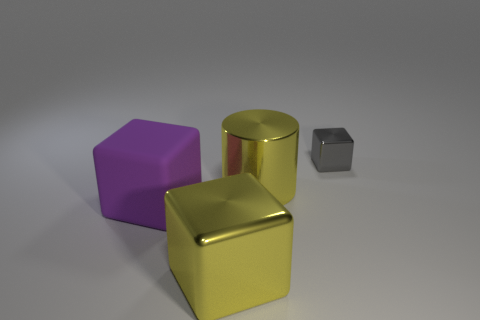Subtract all large matte cubes. How many cubes are left? 2 Subtract all purple cubes. How many cubes are left? 2 Subtract 1 cylinders. How many cylinders are left? 0 Add 4 large purple rubber cubes. How many objects exist? 8 Subtract all yellow cubes. Subtract all gray spheres. How many cubes are left? 2 Subtract all gray balls. How many red cylinders are left? 0 Subtract all big yellow shiny cylinders. Subtract all big purple metal objects. How many objects are left? 3 Add 4 big purple rubber blocks. How many big purple rubber blocks are left? 5 Add 4 yellow objects. How many yellow objects exist? 6 Subtract 0 brown cubes. How many objects are left? 4 